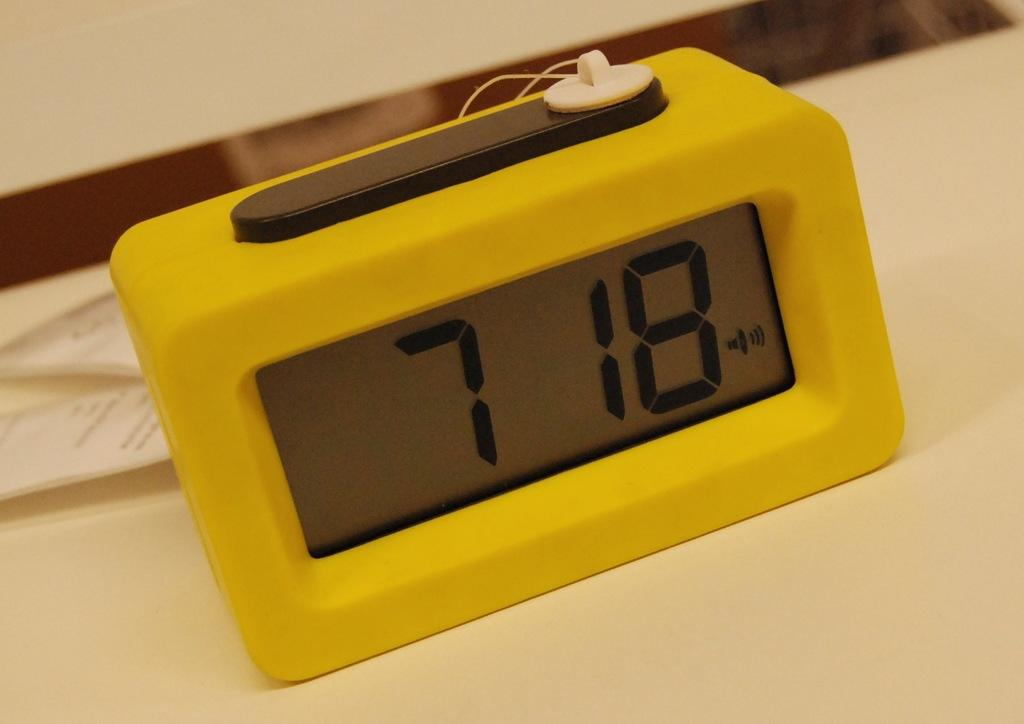Provide a one-sentence caption for the provided image. Yellow clock sits on a table and reads 7 18. 